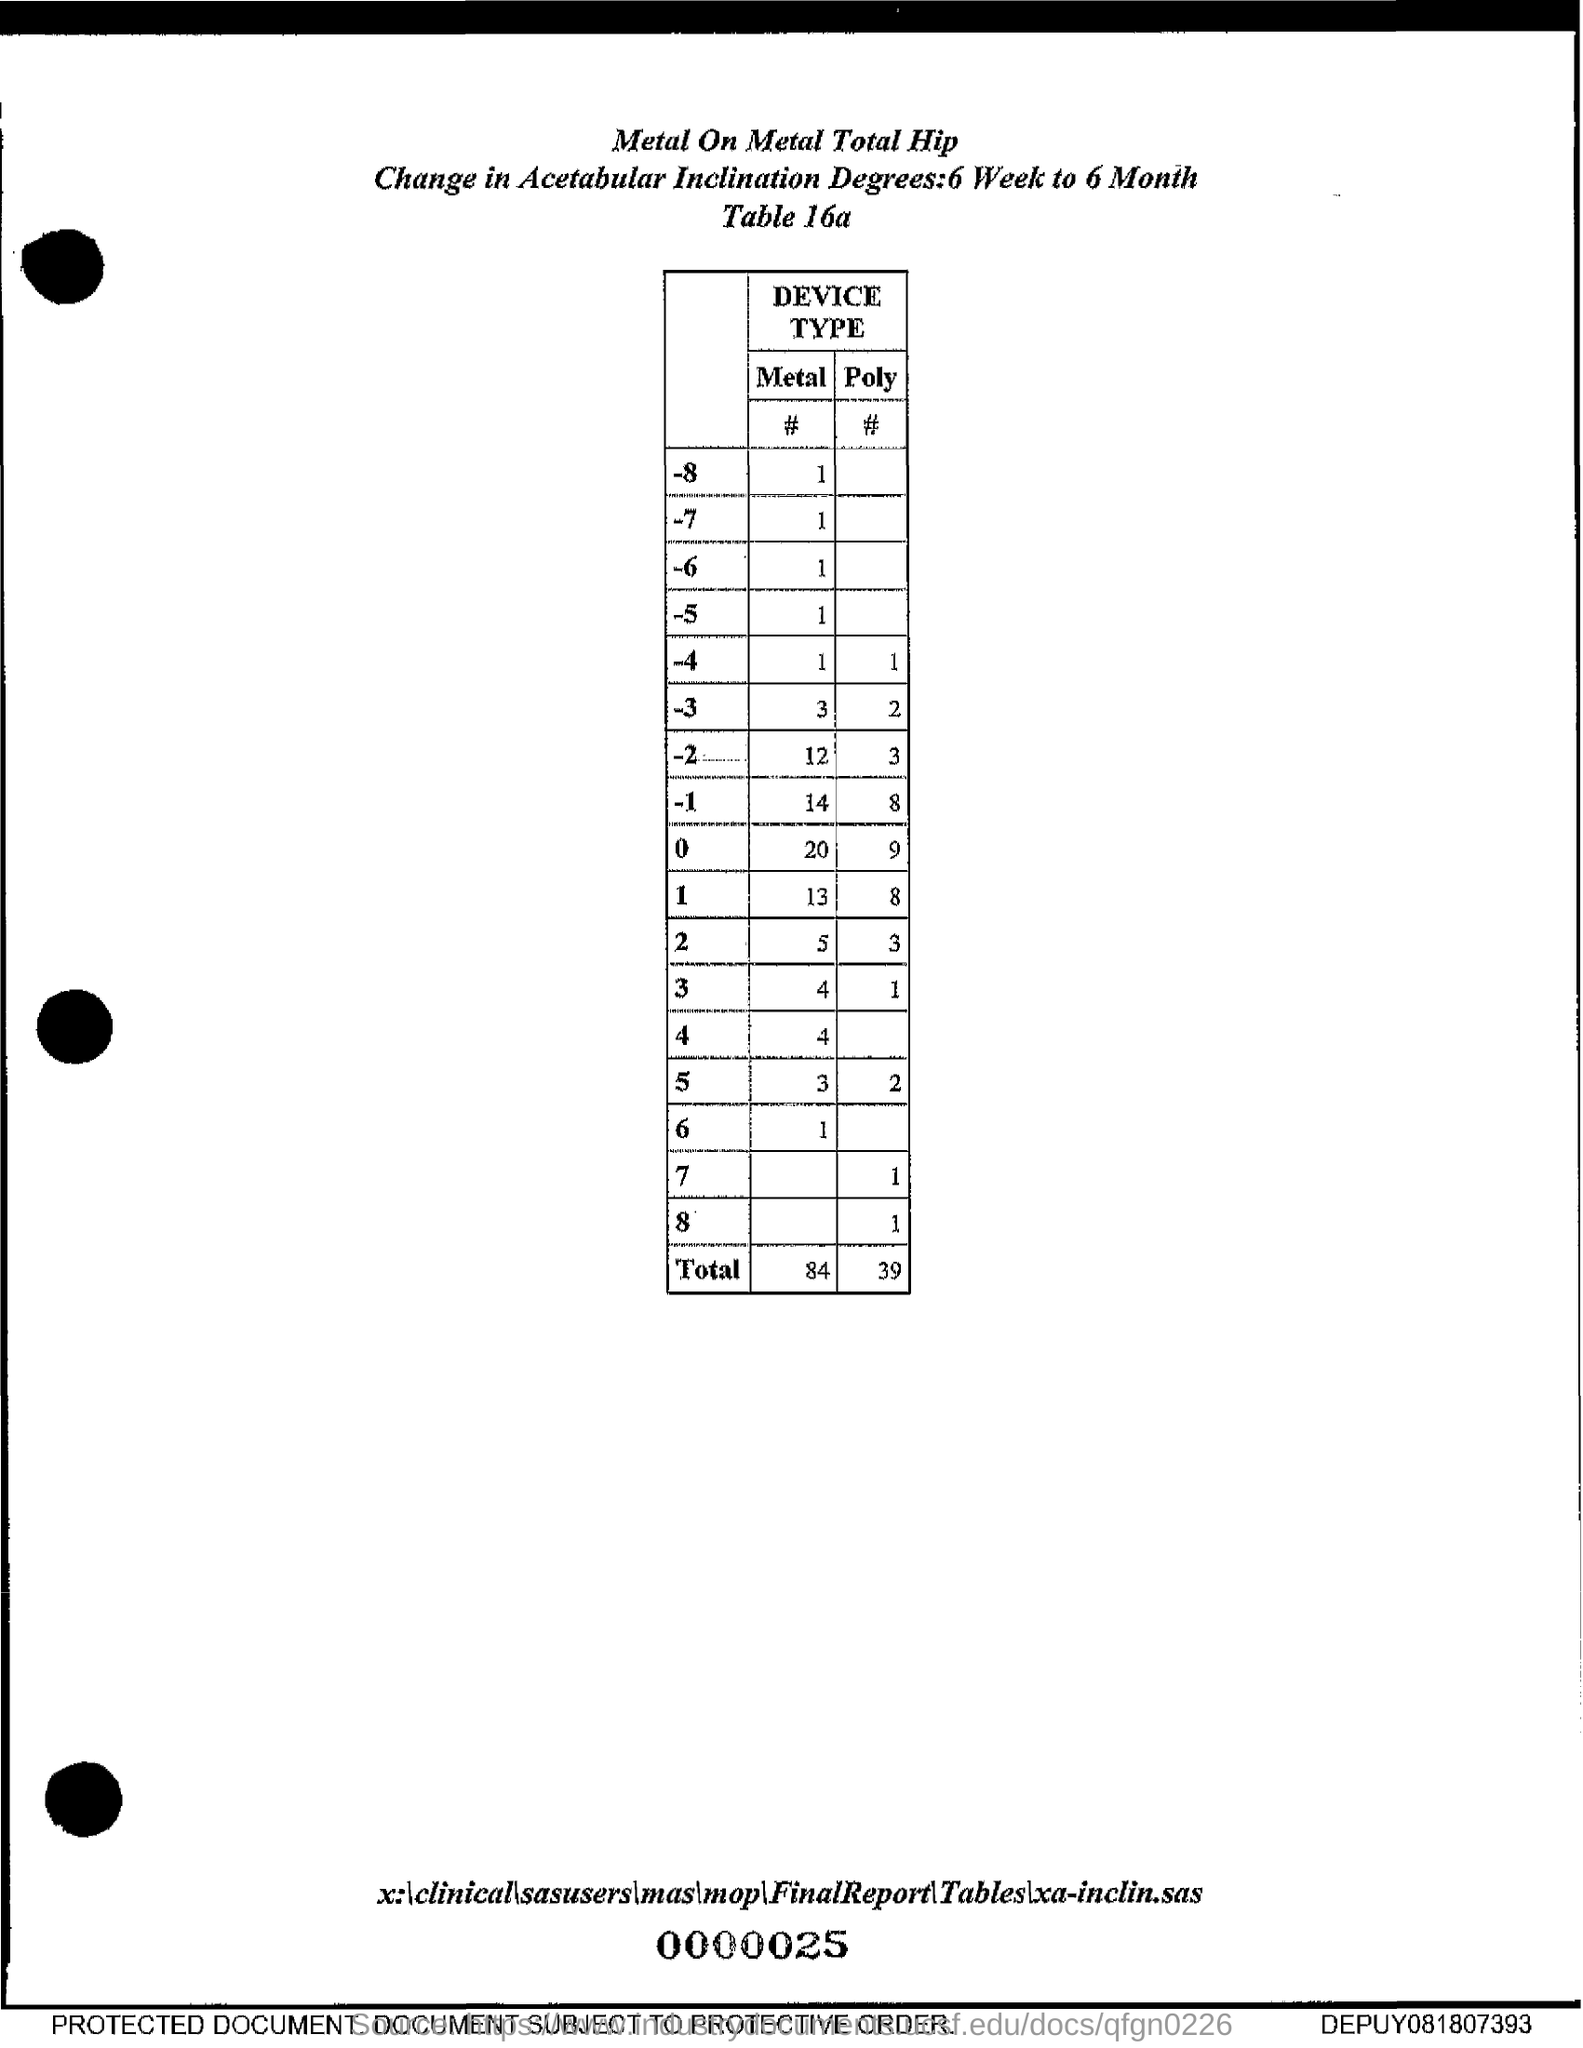What is the Total Metal # ?
Keep it short and to the point. 84. What is the Total Poly #?
Your response must be concise. 39. 